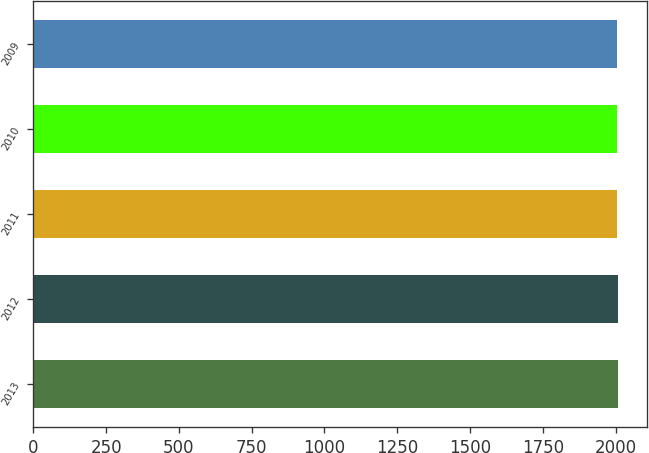Convert chart to OTSL. <chart><loc_0><loc_0><loc_500><loc_500><bar_chart><fcel>2013<fcel>2012<fcel>2011<fcel>2010<fcel>2009<nl><fcel>2008<fcel>2007<fcel>2006<fcel>2005<fcel>2004<nl></chart> 